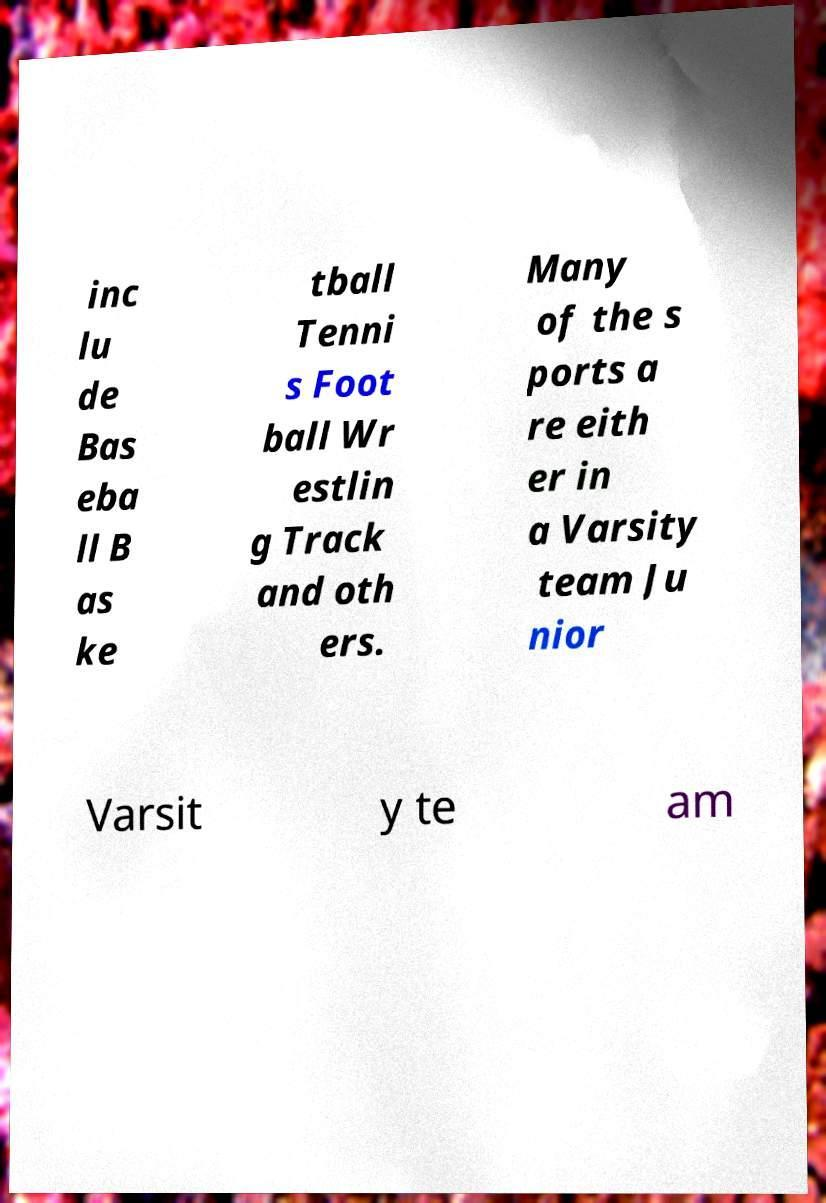I need the written content from this picture converted into text. Can you do that? inc lu de Bas eba ll B as ke tball Tenni s Foot ball Wr estlin g Track and oth ers. Many of the s ports a re eith er in a Varsity team Ju nior Varsit y te am 